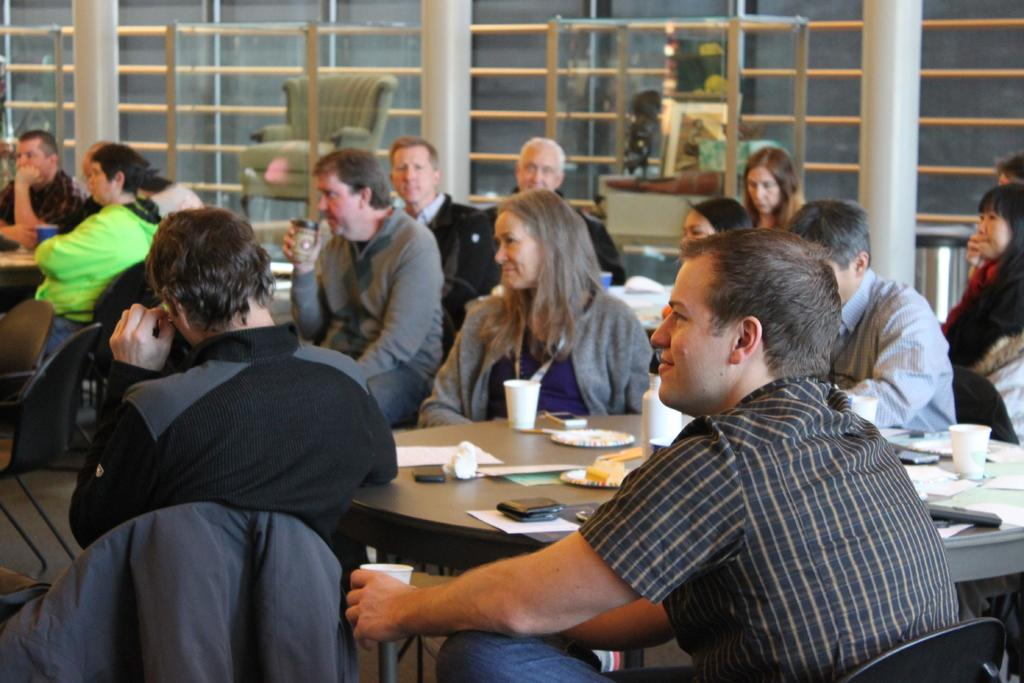What are the people in the image doing? The people in the image are sitting on chairs. What can be seen through the windows in the image? Windows are visible in the image, but the conversation does not provide information about what can be seen through them. What is placed on the table in the image? The facts do not specify what objects are placed on the table. What type of locket is hanging from the neck of the person sitting on the chair? There is no mention of a locket or any jewelry in the image. How much waste is visible in the image? The image does not contain any waste, as the facts provided do not mention any waste. 